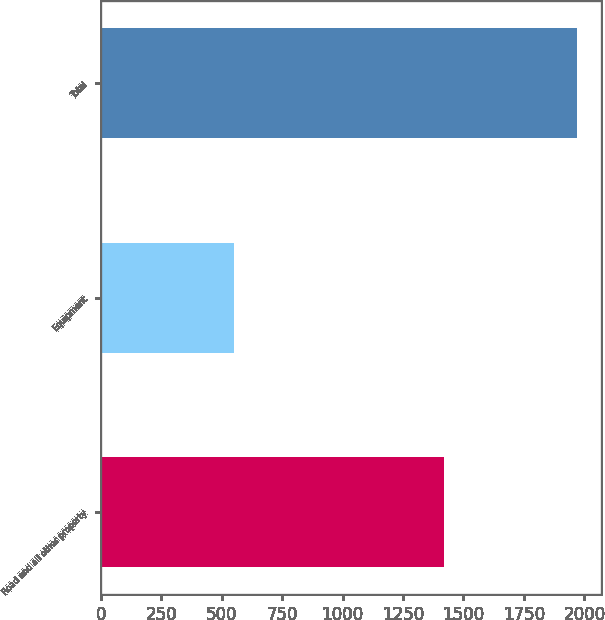Convert chart. <chart><loc_0><loc_0><loc_500><loc_500><bar_chart><fcel>Road and all other property<fcel>Equipment<fcel>Total<nl><fcel>1421<fcel>550<fcel>1971<nl></chart> 